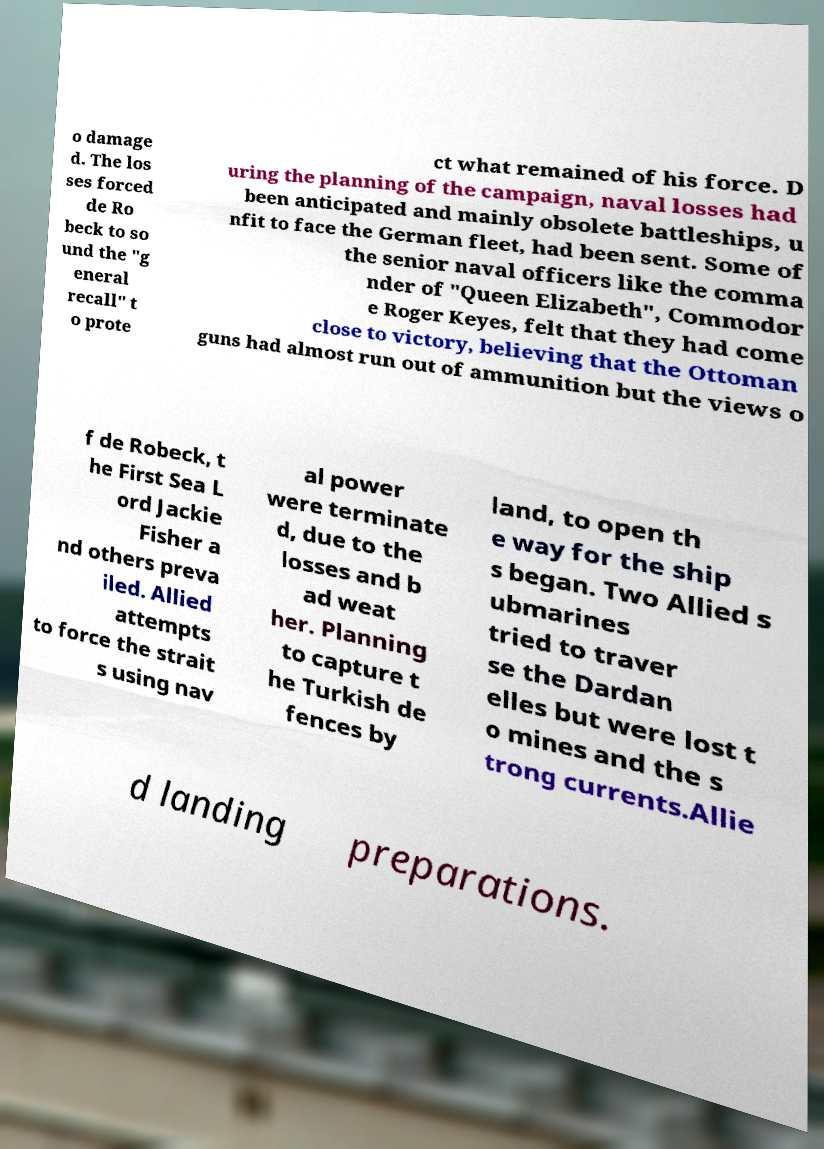For documentation purposes, I need the text within this image transcribed. Could you provide that? o damage d. The los ses forced de Ro beck to so und the "g eneral recall" t o prote ct what remained of his force. D uring the planning of the campaign, naval losses had been anticipated and mainly obsolete battleships, u nfit to face the German fleet, had been sent. Some of the senior naval officers like the comma nder of "Queen Elizabeth", Commodor e Roger Keyes, felt that they had come close to victory, believing that the Ottoman guns had almost run out of ammunition but the views o f de Robeck, t he First Sea L ord Jackie Fisher a nd others preva iled. Allied attempts to force the strait s using nav al power were terminate d, due to the losses and b ad weat her. Planning to capture t he Turkish de fences by land, to open th e way for the ship s began. Two Allied s ubmarines tried to traver se the Dardan elles but were lost t o mines and the s trong currents.Allie d landing preparations. 